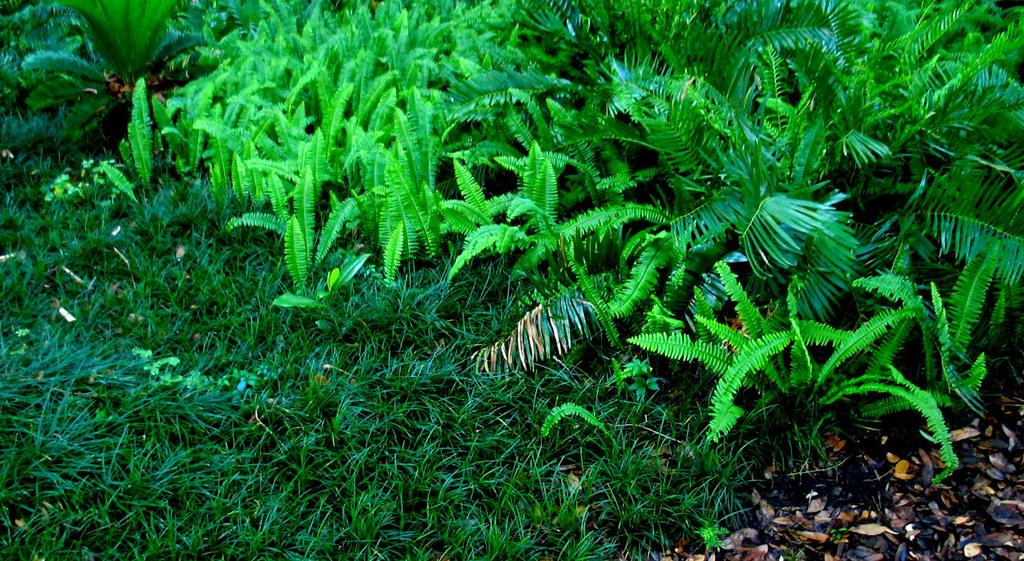What type of vegetation is present on the land in the image? There is grass on the land in the image. What color are the plants in the image? The plants in the image are green. Can you describe the dried leaves in the image? The dried leaves are located on the right side of the image. What type of lunch is being served in the room in the image? There is no room or lunch present in the image; it features grass, green plants, and dried leaves. 